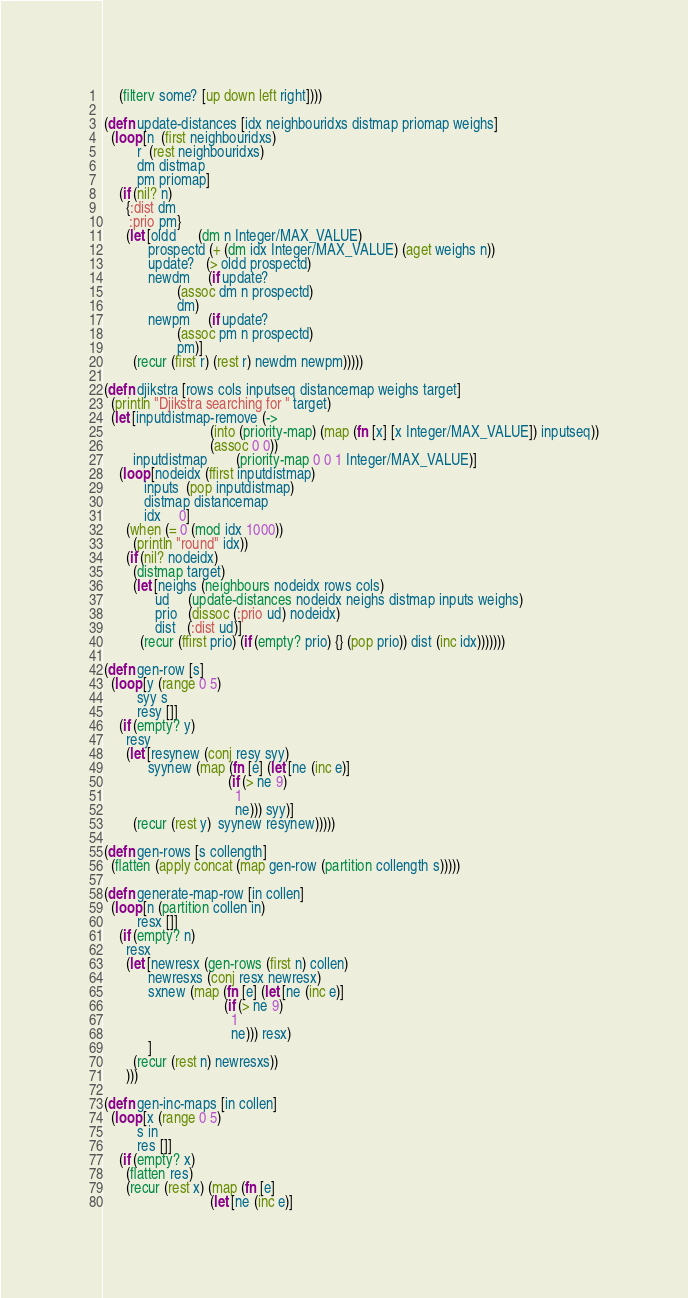Convert code to text. <code><loc_0><loc_0><loc_500><loc_500><_Clojure_>    (filterv some? [up down left right])))

(defn update-distances [idx neighbouridxs distmap priomap weighs]
  (loop [n  (first neighbouridxs)
         r  (rest neighbouridxs)
         dm distmap
         pm priomap]
    (if (nil? n)
      {:dist dm
       :prio pm}
      (let [oldd      (dm n Integer/MAX_VALUE)
            prospectd (+ (dm idx Integer/MAX_VALUE) (aget weighs n))
            update?   (> oldd prospectd)
            newdm     (if update?
                    (assoc dm n prospectd)
                    dm)
            newpm     (if update?
                    (assoc pm n prospectd)
                    pm)]
        (recur (first r) (rest r) newdm newpm)))))

(defn djikstra [rows cols inputseq distancemap weighs target]
  (println "Djikstra searching for " target)
  (let [inputdistmap-remove (->
                             (into (priority-map) (map (fn [x] [x Integer/MAX_VALUE]) inputseq))
                             (assoc 0 0))
        inputdistmap        (priority-map 0 0 1 Integer/MAX_VALUE)]
    (loop [nodeidx (ffirst inputdistmap)
           inputs  (pop inputdistmap)
           distmap distancemap
           idx     0]
      (when (= 0 (mod idx 1000))
        (println "round" idx))
      (if (nil? nodeidx)
        (distmap target)
        (let [neighs (neighbours nodeidx rows cols)
              ud     (update-distances nodeidx neighs distmap inputs weighs)
              prio   (dissoc (:prio ud) nodeidx)
              dist   (:dist ud)]
          (recur (ffirst prio) (if (empty? prio) {} (pop prio)) dist (inc idx)))))))

(defn gen-row [s]
  (loop [y (range 0 5)
         syy s
         resy []]
    (if (empty? y)
      resy
      (let [resynew (conj resy syy)
            syynew (map (fn [e] (let [ne (inc e)]
                                  (if (> ne 9)
                                    1
                                    ne))) syy)]
        (recur (rest y)  syynew resynew)))))

(defn gen-rows [s collength]
  (flatten (apply concat (map gen-row (partition collength s)))))

(defn generate-map-row [in collen]
  (loop [n (partition collen in)
         resx []]
    (if (empty? n)
      resx
      (let [newresx (gen-rows (first n) collen)
            newresxs (conj resx newresx)
            sxnew (map (fn [e] (let [ne (inc e)]
                                 (if (> ne 9)
                                   1
                                   ne))) resx)
            ]
        (recur (rest n) newresxs))
      )))

(defn gen-inc-maps [in collen]
  (loop [x (range 0 5)
         s in
         res []]
    (if (empty? x)
      (flatten res)
      (recur (rest x) (map (fn [e]
                             (let [ne (inc e)]</code> 